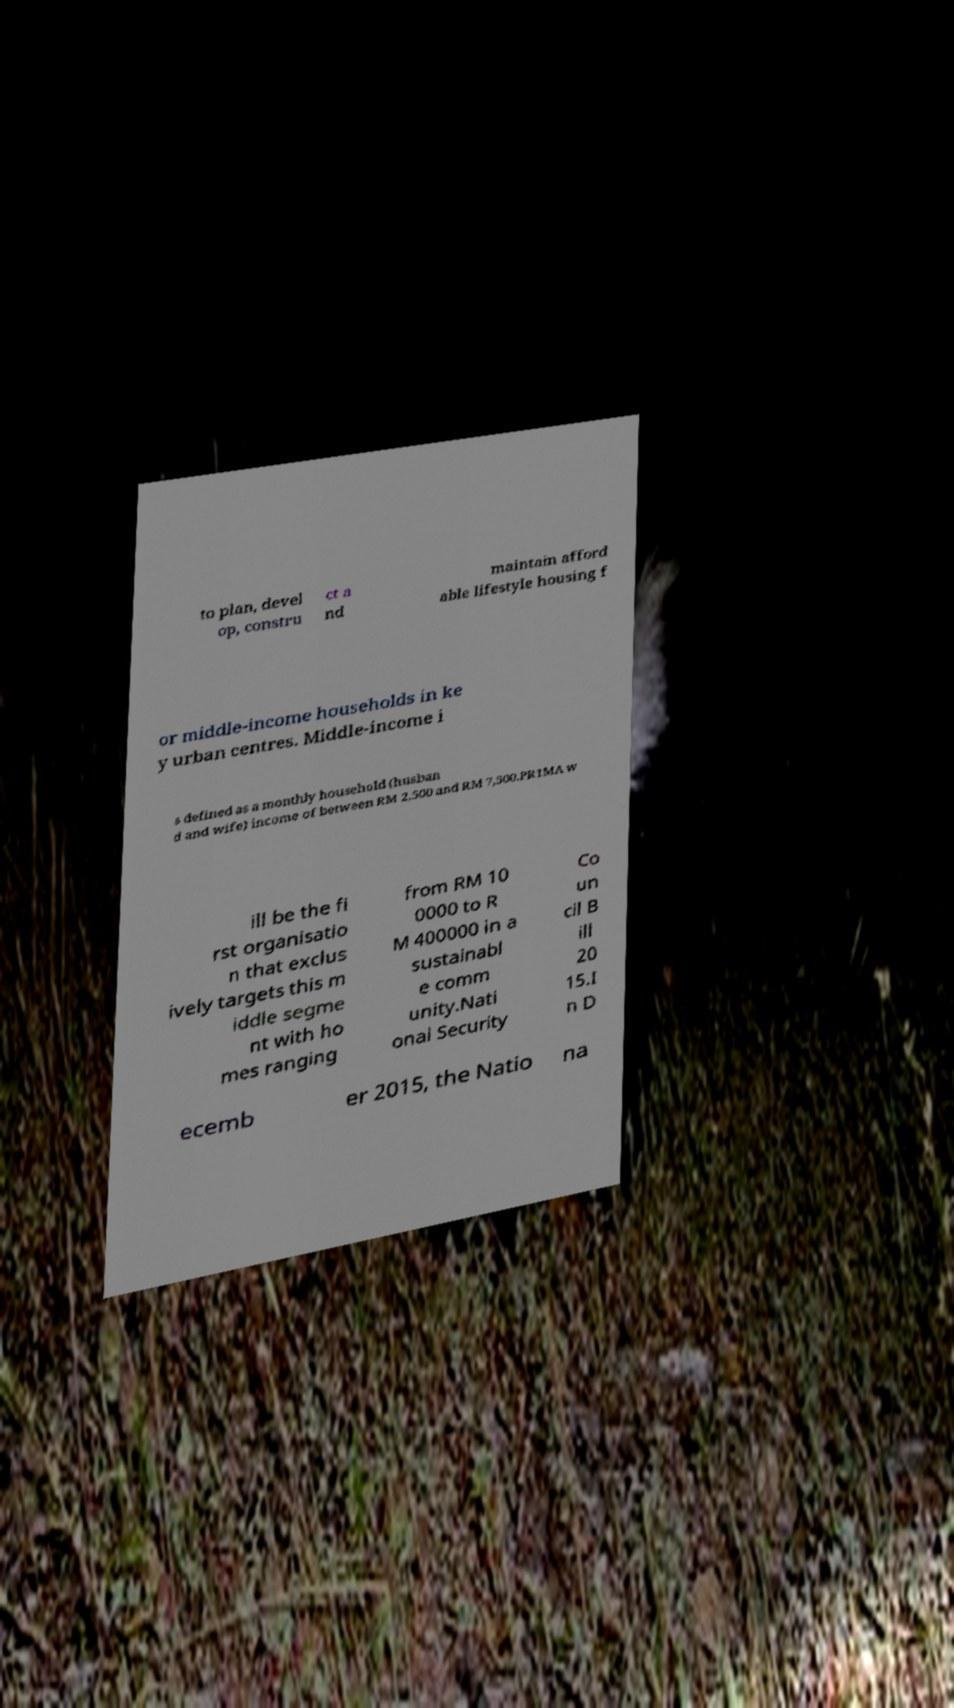Can you read and provide the text displayed in the image?This photo seems to have some interesting text. Can you extract and type it out for me? to plan, devel op, constru ct a nd maintain afford able lifestyle housing f or middle-income households in ke y urban centres. Middle-income i s defined as a monthly household (husban d and wife) income of between RM 2,500 and RM 7,500.PR1MA w ill be the fi rst organisatio n that exclus ively targets this m iddle segme nt with ho mes ranging from RM 10 0000 to R M 400000 in a sustainabl e comm unity.Nati onal Security Co un cil B ill 20 15.I n D ecemb er 2015, the Natio na 